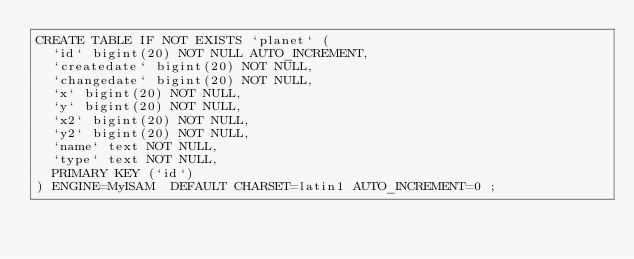Convert code to text. <code><loc_0><loc_0><loc_500><loc_500><_SQL_>CREATE TABLE IF NOT EXISTS `planet` (
  `id` bigint(20) NOT NULL AUTO_INCREMENT,
  `createdate` bigint(20) NOT NULL,
  `changedate` bigint(20) NOT NULL,
  `x` bigint(20) NOT NULL,
  `y` bigint(20) NOT NULL,
  `x2` bigint(20) NOT NULL,
  `y2` bigint(20) NOT NULL,
  `name` text NOT NULL,
  `type` text NOT NULL,
  PRIMARY KEY (`id`)
) ENGINE=MyISAM  DEFAULT CHARSET=latin1 AUTO_INCREMENT=0 ;
</code> 